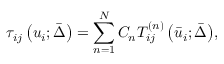<formula> <loc_0><loc_0><loc_500><loc_500>{ \tau _ { i j } } \left ( { { u _ { i } } ; \bar { \Delta } } \right ) = \sum _ { n = 1 } ^ { N } { { C _ { n } } T _ { i j } ^ { \left ( n \right ) } \left ( { { { \bar { u } } _ { i } } ; \bar { \Delta } } \right ) } ,</formula> 